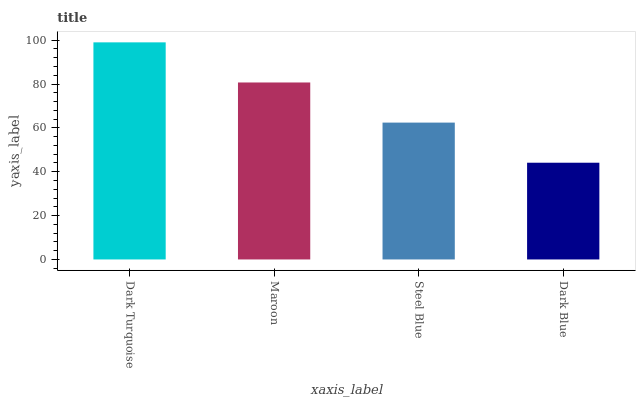Is Dark Blue the minimum?
Answer yes or no. Yes. Is Dark Turquoise the maximum?
Answer yes or no. Yes. Is Maroon the minimum?
Answer yes or no. No. Is Maroon the maximum?
Answer yes or no. No. Is Dark Turquoise greater than Maroon?
Answer yes or no. Yes. Is Maroon less than Dark Turquoise?
Answer yes or no. Yes. Is Maroon greater than Dark Turquoise?
Answer yes or no. No. Is Dark Turquoise less than Maroon?
Answer yes or no. No. Is Maroon the high median?
Answer yes or no. Yes. Is Steel Blue the low median?
Answer yes or no. Yes. Is Steel Blue the high median?
Answer yes or no. No. Is Maroon the low median?
Answer yes or no. No. 